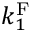Convert formula to latex. <formula><loc_0><loc_0><loc_500><loc_500>k _ { 1 } ^ { F }</formula> 